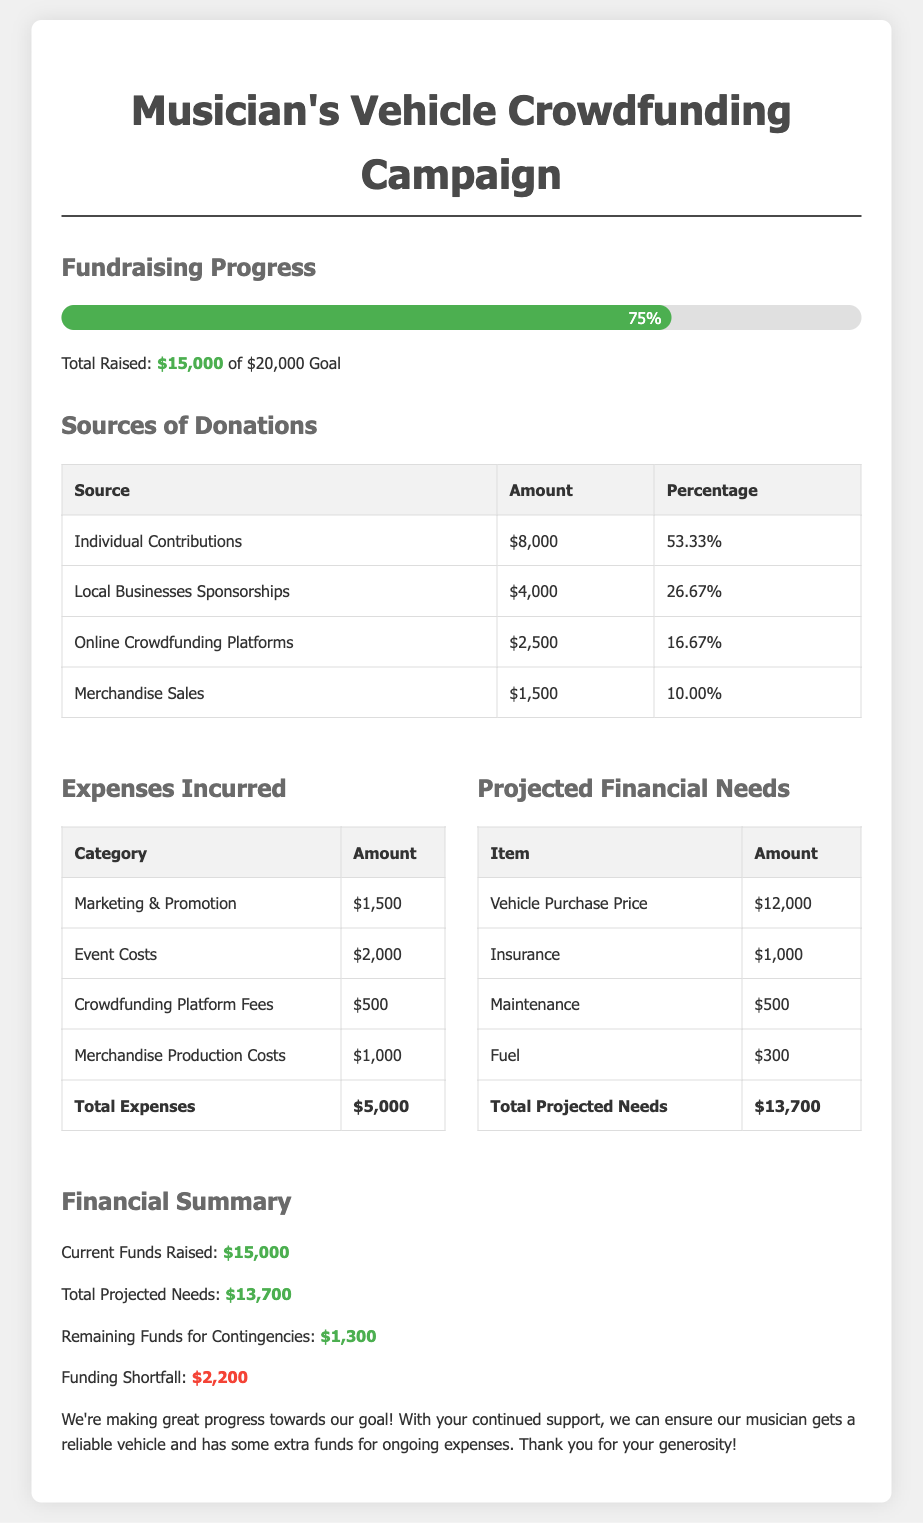What is the total amount raised? The total amount raised is listed in the Financial Summary section as $15,000.
Answer: $15,000 What percentage of total donations comes from individual contributions? The percentage for individual contributions is provided in the Sources of Donations table as 53.33%.
Answer: 53.33% What is the total amount of expenses incurred? The total expenses are summarized in the Expenses Incurred section as $5,000.
Answer: $5,000 What is the purchase price projected for the vehicle? The projected purchase price for the vehicle is specified in the Projected Financial Needs section as $12,000.
Answer: $12,000 What is the remaining amount available for contingencies? The remaining funds for contingencies are calculated in the Financial Summary as $1,300.
Answer: $1,300 What is the total projected financial need? The total projected financial needs are shown in the Projected Financial Needs section as $13,700.
Answer: $13,700 What is the funding shortfall amount? The funding shortfall is indicated in the Financial Summary as $2,200.
Answer: $2,200 What category has the highest expense? Based on the Expenses Incurred table, the category with the highest expense is Event Costs at $2,000.
Answer: Event Costs 